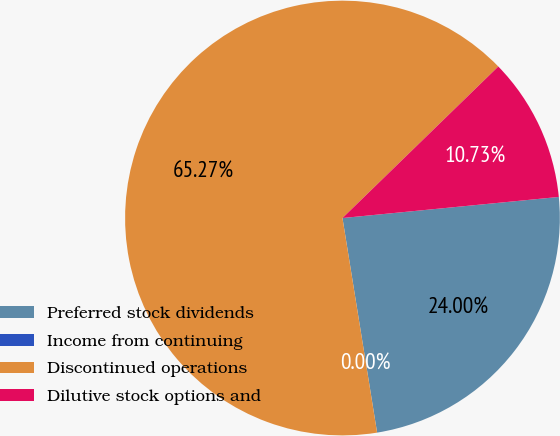Convert chart. <chart><loc_0><loc_0><loc_500><loc_500><pie_chart><fcel>Preferred stock dividends<fcel>Income from continuing<fcel>Discontinued operations<fcel>Dilutive stock options and<nl><fcel>24.0%<fcel>0.0%<fcel>65.27%<fcel>10.73%<nl></chart> 